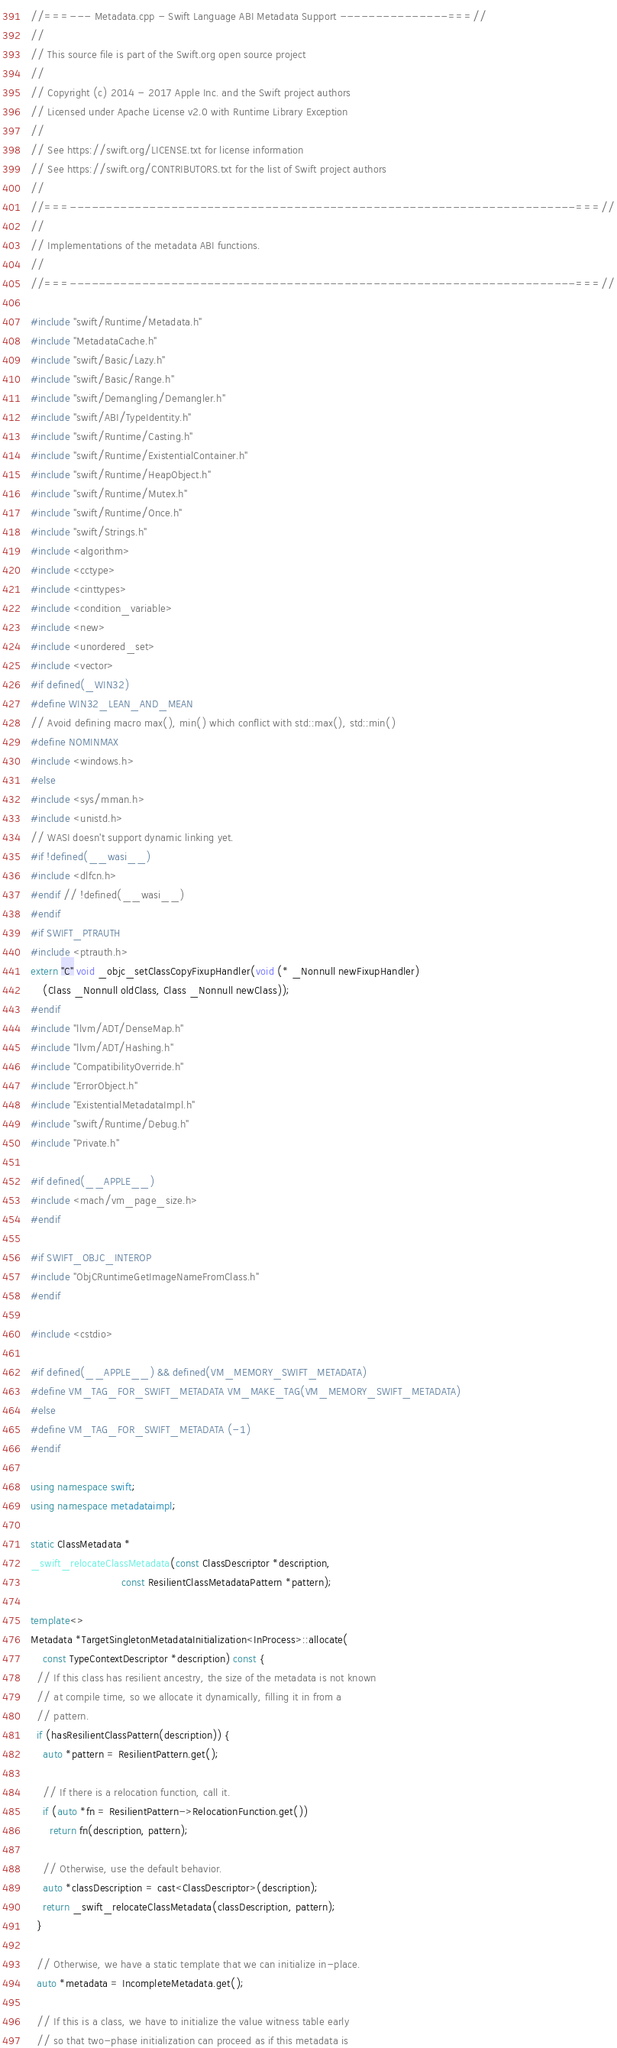<code> <loc_0><loc_0><loc_500><loc_500><_C++_>//===--- Metadata.cpp - Swift Language ABI Metadata Support ---------------===//
//
// This source file is part of the Swift.org open source project
//
// Copyright (c) 2014 - 2017 Apple Inc. and the Swift project authors
// Licensed under Apache License v2.0 with Runtime Library Exception
//
// See https://swift.org/LICENSE.txt for license information
// See https://swift.org/CONTRIBUTORS.txt for the list of Swift project authors
//
//===----------------------------------------------------------------------===//
//
// Implementations of the metadata ABI functions.
//
//===----------------------------------------------------------------------===//

#include "swift/Runtime/Metadata.h"
#include "MetadataCache.h"
#include "swift/Basic/Lazy.h"
#include "swift/Basic/Range.h"
#include "swift/Demangling/Demangler.h"
#include "swift/ABI/TypeIdentity.h"
#include "swift/Runtime/Casting.h"
#include "swift/Runtime/ExistentialContainer.h"
#include "swift/Runtime/HeapObject.h"
#include "swift/Runtime/Mutex.h"
#include "swift/Runtime/Once.h"
#include "swift/Strings.h"
#include <algorithm>
#include <cctype>
#include <cinttypes>
#include <condition_variable>
#include <new>
#include <unordered_set>
#include <vector>
#if defined(_WIN32)
#define WIN32_LEAN_AND_MEAN
// Avoid defining macro max(), min() which conflict with std::max(), std::min()
#define NOMINMAX
#include <windows.h>
#else
#include <sys/mman.h>
#include <unistd.h>
// WASI doesn't support dynamic linking yet.
#if !defined(__wasi__)
#include <dlfcn.h>
#endif // !defined(__wasi__)
#endif
#if SWIFT_PTRAUTH
#include <ptrauth.h>
extern "C" void _objc_setClassCopyFixupHandler(void (* _Nonnull newFixupHandler)
    (Class _Nonnull oldClass, Class _Nonnull newClass));
#endif
#include "llvm/ADT/DenseMap.h"
#include "llvm/ADT/Hashing.h"
#include "CompatibilityOverride.h"
#include "ErrorObject.h"
#include "ExistentialMetadataImpl.h"
#include "swift/Runtime/Debug.h"
#include "Private.h"

#if defined(__APPLE__)
#include <mach/vm_page_size.h>
#endif

#if SWIFT_OBJC_INTEROP
#include "ObjCRuntimeGetImageNameFromClass.h"
#endif

#include <cstdio>

#if defined(__APPLE__) && defined(VM_MEMORY_SWIFT_METADATA)
#define VM_TAG_FOR_SWIFT_METADATA VM_MAKE_TAG(VM_MEMORY_SWIFT_METADATA)
#else
#define VM_TAG_FOR_SWIFT_METADATA (-1)
#endif

using namespace swift;
using namespace metadataimpl;

static ClassMetadata *
_swift_relocateClassMetadata(const ClassDescriptor *description,
                             const ResilientClassMetadataPattern *pattern);

template<>
Metadata *TargetSingletonMetadataInitialization<InProcess>::allocate(
    const TypeContextDescriptor *description) const {
  // If this class has resilient ancestry, the size of the metadata is not known
  // at compile time, so we allocate it dynamically, filling it in from a
  // pattern.
  if (hasResilientClassPattern(description)) {
    auto *pattern = ResilientPattern.get();

    // If there is a relocation function, call it.
    if (auto *fn = ResilientPattern->RelocationFunction.get())
      return fn(description, pattern);

    // Otherwise, use the default behavior.
    auto *classDescription = cast<ClassDescriptor>(description);
    return _swift_relocateClassMetadata(classDescription, pattern);
  }

  // Otherwise, we have a static template that we can initialize in-place.
  auto *metadata = IncompleteMetadata.get();

  // If this is a class, we have to initialize the value witness table early
  // so that two-phase initialization can proceed as if this metadata is</code> 